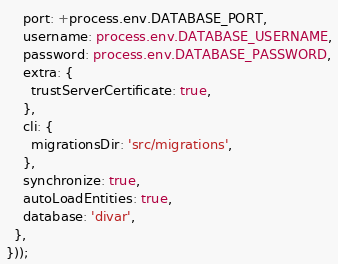<code> <loc_0><loc_0><loc_500><loc_500><_TypeScript_>    port: +process.env.DATABASE_PORT,
    username: process.env.DATABASE_USERNAME,
    password: process.env.DATABASE_PASSWORD,
    extra: {
      trustServerCertificate: true,
    },
    cli: {
      migrationsDir: 'src/migrations',
    },
    synchronize: true,
    autoLoadEntities: true,
    database: 'divar',
  },
}));
</code> 